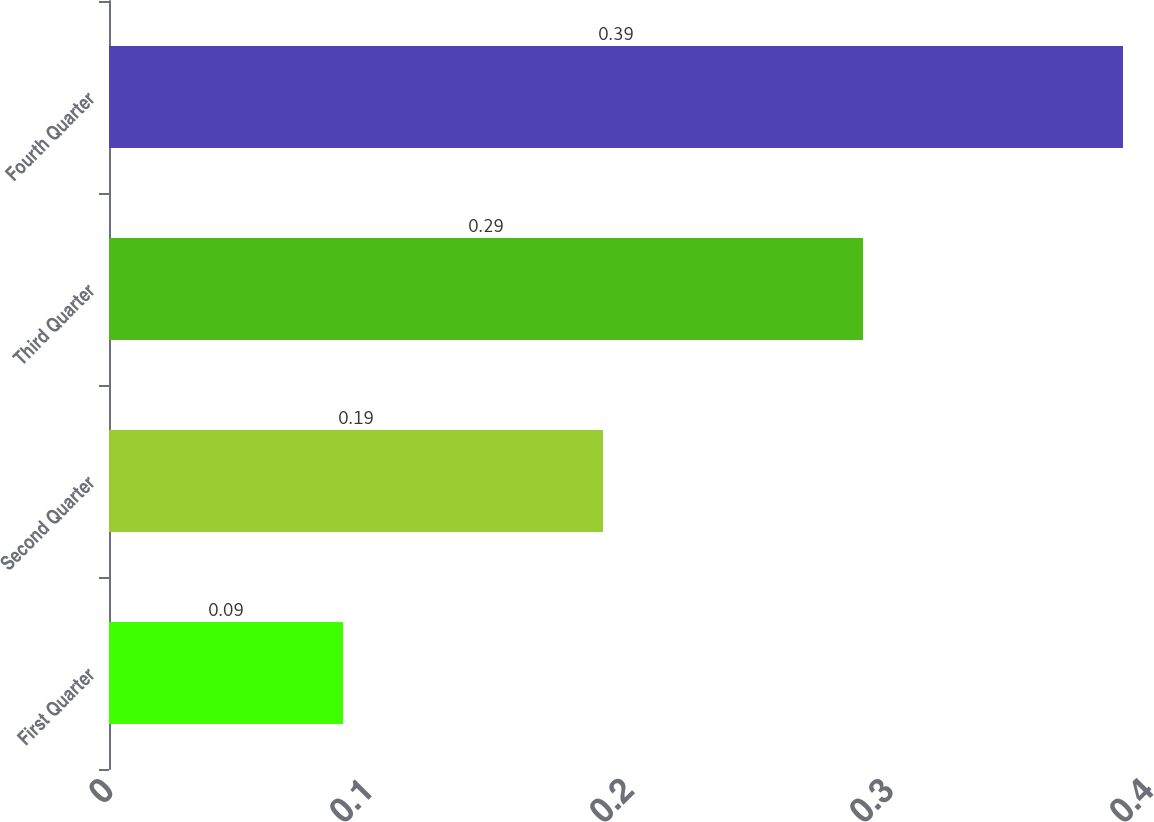Convert chart. <chart><loc_0><loc_0><loc_500><loc_500><bar_chart><fcel>First Quarter<fcel>Second Quarter<fcel>Third Quarter<fcel>Fourth Quarter<nl><fcel>0.09<fcel>0.19<fcel>0.29<fcel>0.39<nl></chart> 